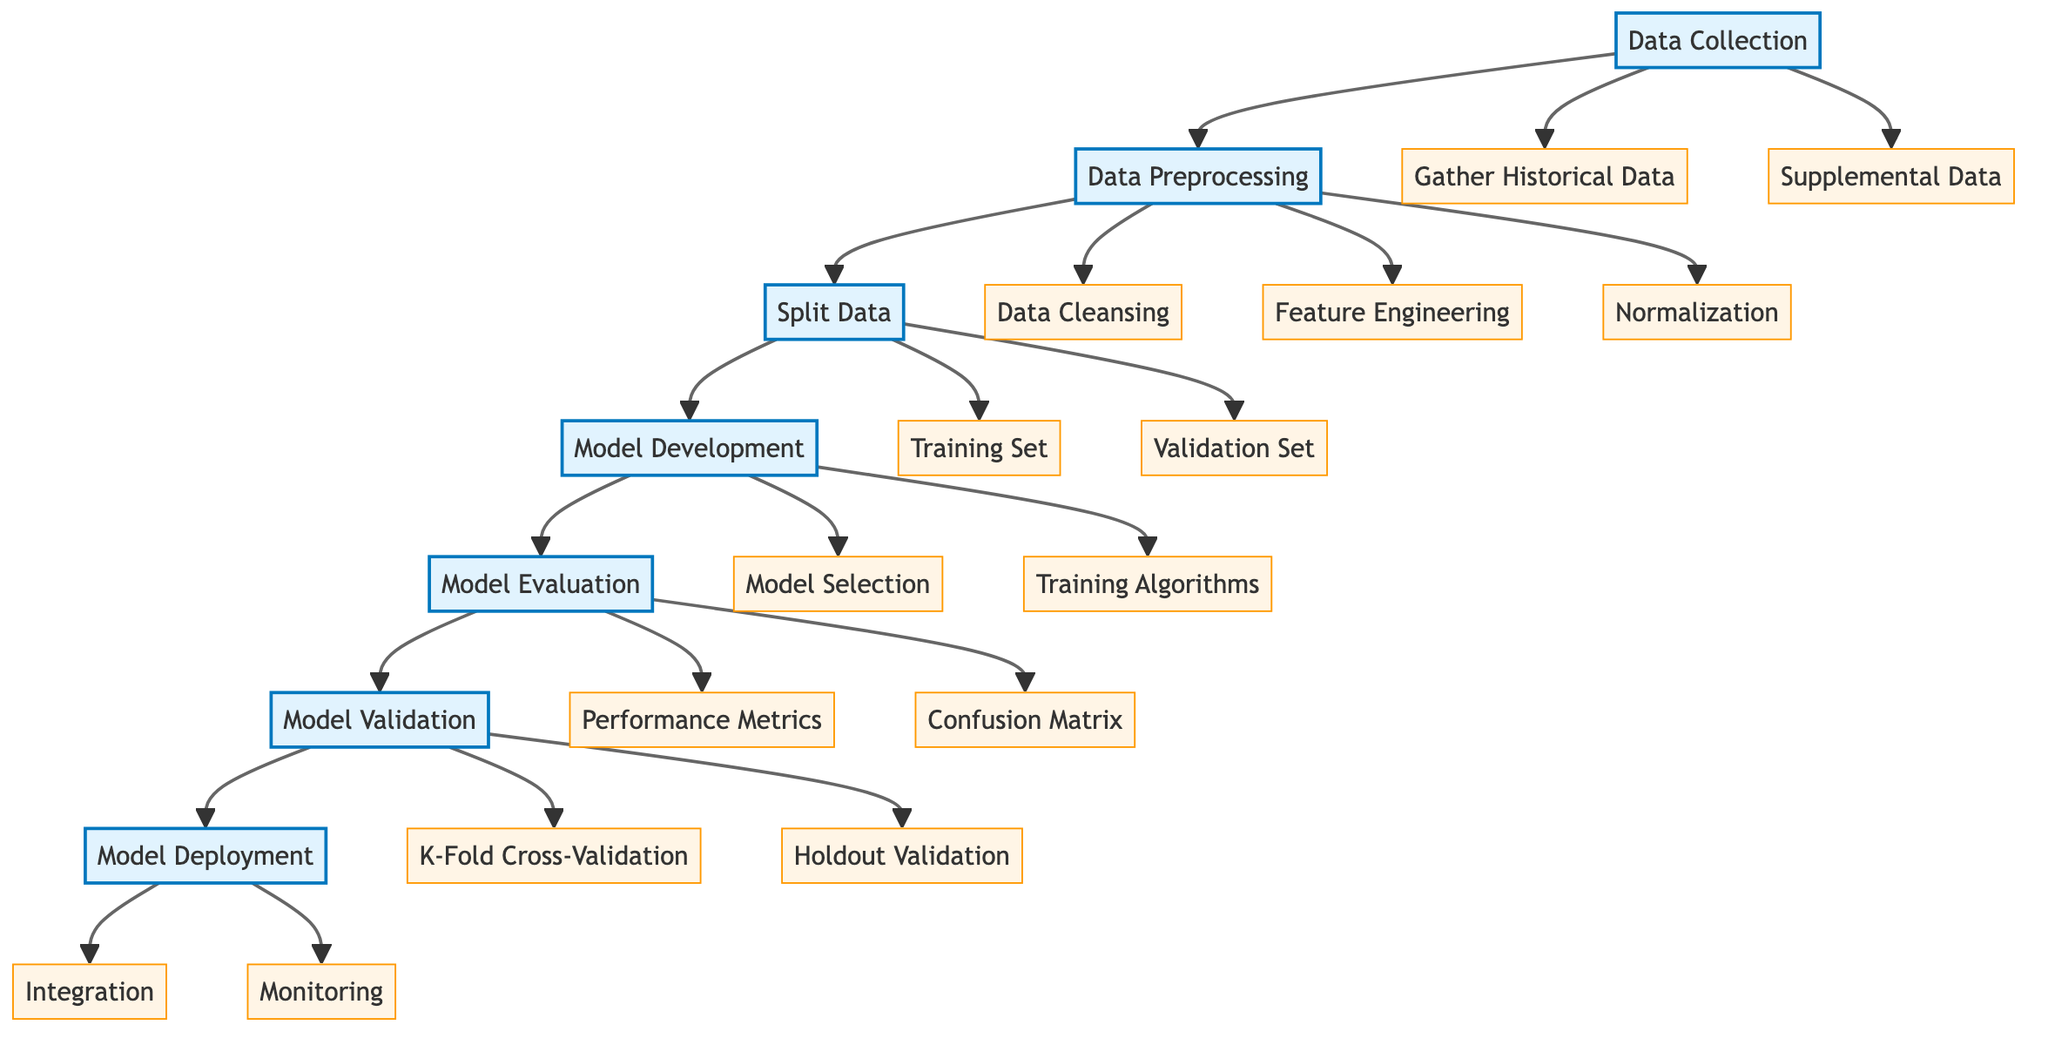What is the first step in training a predictive model? The first step in the diagram is "Data Collection", which is represented as the starting node before other steps follow.
Answer: Data Collection How many main steps are there in the flow chart? By counting the nodes, there are a total of seven main steps outlined in the flow chart, which include Data Collection, Data Preprocessing, Split Data, Model Development, Model Evaluation, Model Validation, and Model Deployment.
Answer: Seven Which step follows Model Evaluation? According to the flow chart, the step that follows Model Evaluation is Model Validation, as it is directly connected to it in the progression of steps.
Answer: Model Validation What percentage of data is typically used for the training set? The flow chart indicates that a typical allocation for the training set is 70-80% of the data, distinguishing it from the validation set.
Answer: 70-80% What are two types of model validation techniques mentioned? The flow chart outlines "K-Fold Cross-Validation" and "Holdout Validation" as the two types of model validation techniques utilized for ensuring robustness in model performance.
Answer: K-Fold Cross-Validation and Holdout Validation Which step involves creating new variables from existing data? The step that involves creating new variables, often referred to as features, is "Feature Engineering", which is a part of the Data Preprocessing stage.
Answer: Feature Engineering Name one type of performance metric used in model evaluation. "Accuracy" is listed as one type of performance metric that can be employed to evaluate model effectiveness within the Model Evaluation section of the flow chart.
Answer: Accuracy What is the last step before deploying the model? The last step before deploying the model is "Model Validation", which is crucial for verifying the performance of the model before it is put into real-world use.
Answer: Model Validation Which subprocess follows the Data Cleansing step? The subprocess that directly follows Data Cleansing is "Feature Engineering", as indicated in the flow chart that shows the order of tasks within Data Preprocessing.
Answer: Feature Engineering 